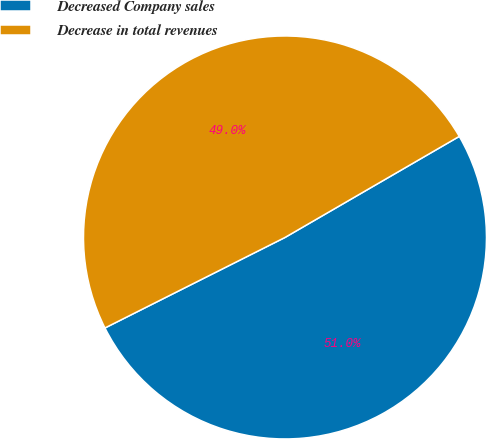Convert chart. <chart><loc_0><loc_0><loc_500><loc_500><pie_chart><fcel>Decreased Company sales<fcel>Decrease in total revenues<nl><fcel>50.95%<fcel>49.05%<nl></chart> 